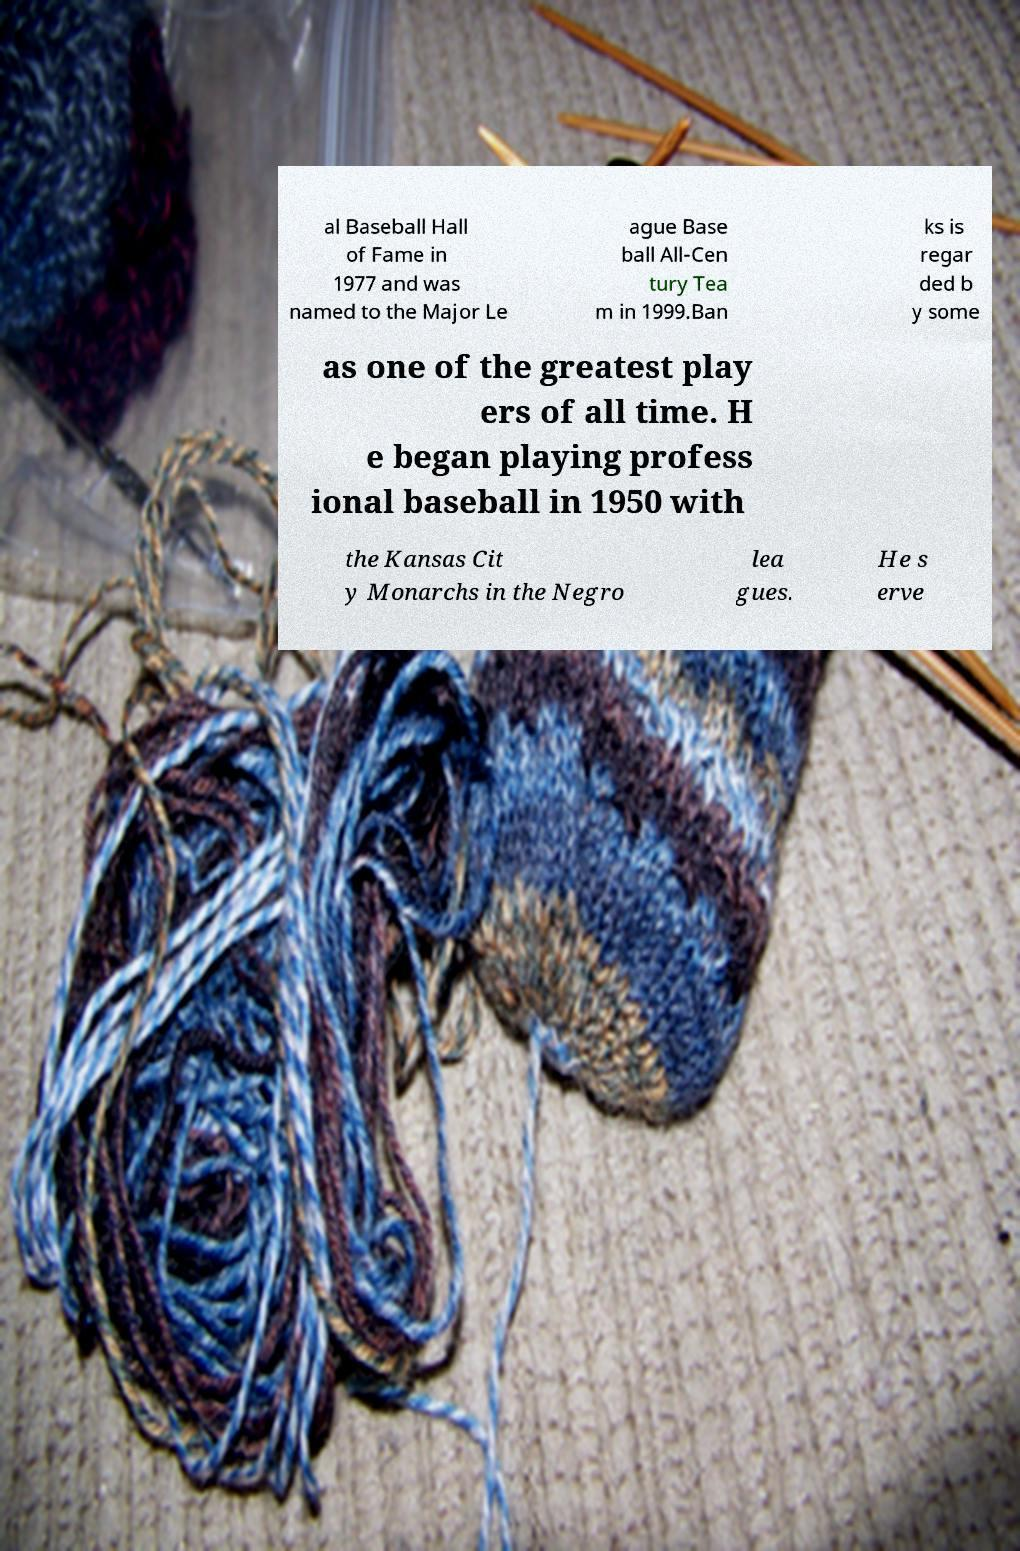For documentation purposes, I need the text within this image transcribed. Could you provide that? al Baseball Hall of Fame in 1977 and was named to the Major Le ague Base ball All-Cen tury Tea m in 1999.Ban ks is regar ded b y some as one of the greatest play ers of all time. H e began playing profess ional baseball in 1950 with the Kansas Cit y Monarchs in the Negro lea gues. He s erve 